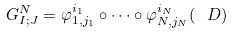Convert formula to latex. <formula><loc_0><loc_0><loc_500><loc_500>G ^ { N } _ { I ; J } = \varphi ^ { i _ { 1 } } _ { 1 , j _ { 1 } } \circ \dots \circ \varphi ^ { i _ { N } } _ { N , j _ { N } } ( \ D )</formula> 